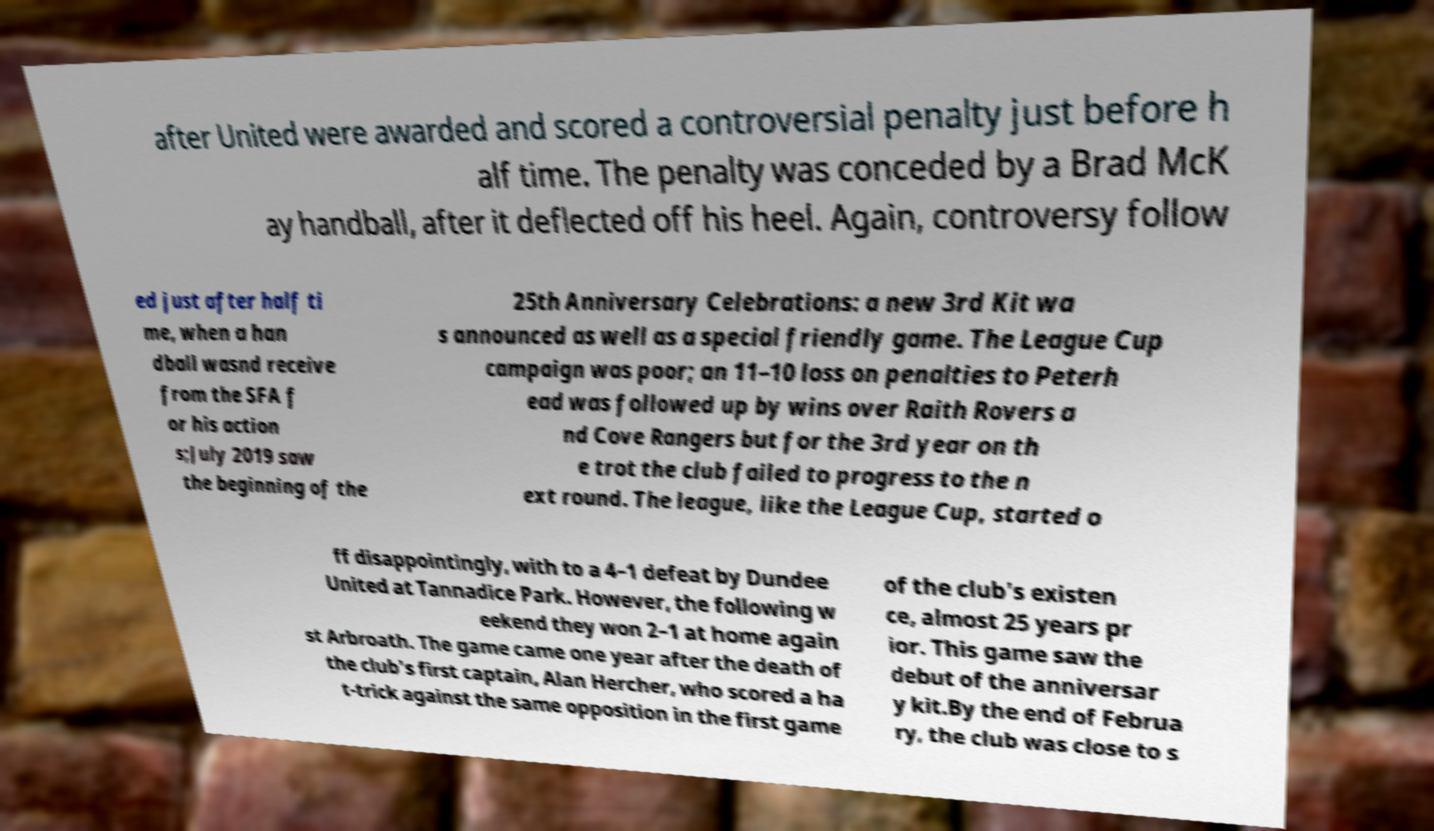Can you accurately transcribe the text from the provided image for me? after United were awarded and scored a controversial penalty just before h alf time. The penalty was conceded by a Brad McK ay handball, after it deflected off his heel. Again, controversy follow ed just after half ti me, when a han dball wasnd receive from the SFA f or his action s;July 2019 saw the beginning of the 25th Anniversary Celebrations: a new 3rd Kit wa s announced as well as a special friendly game. The League Cup campaign was poor; an 11–10 loss on penalties to Peterh ead was followed up by wins over Raith Rovers a nd Cove Rangers but for the 3rd year on th e trot the club failed to progress to the n ext round. The league, like the League Cup, started o ff disappointingly, with to a 4–1 defeat by Dundee United at Tannadice Park. However, the following w eekend they won 2–1 at home again st Arbroath. The game came one year after the death of the club's first captain, Alan Hercher, who scored a ha t-trick against the same opposition in the first game of the club's existen ce, almost 25 years pr ior. This game saw the debut of the anniversar y kit.By the end of Februa ry, the club was close to s 